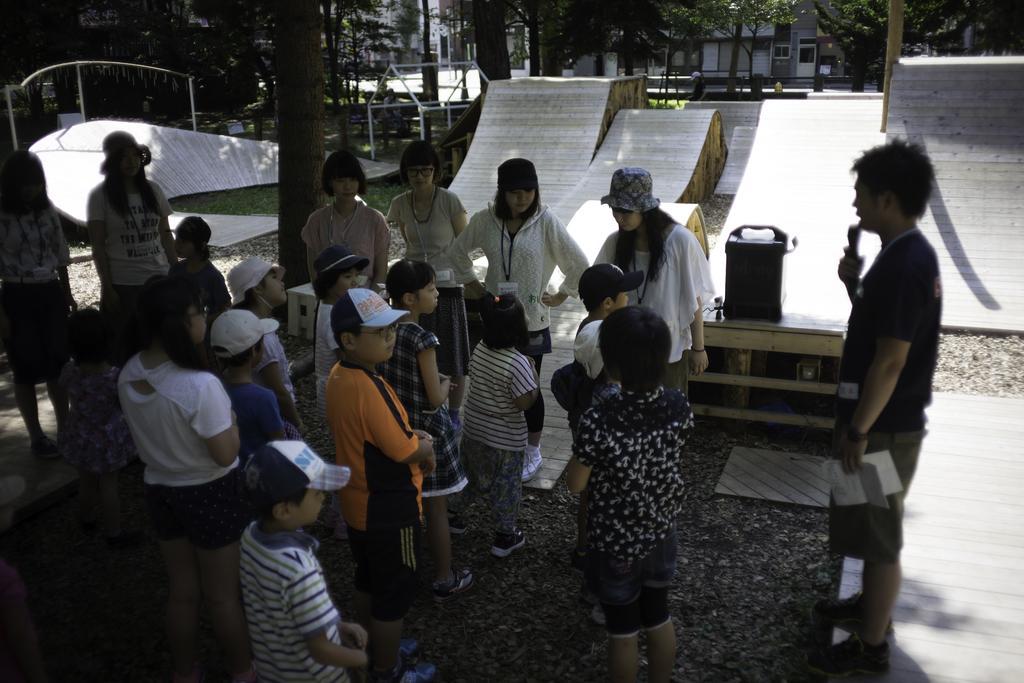How would you summarize this image in a sentence or two? In this picture, we see children are standing. In front of them, we see the girls in white dresses are standing. Behind them, we see a table on which black color object is placed. The man on the right side is holding a paper and a microphone in his hands. He is talking on the microphone. Behind them, we see the ramps. There are trees and buildings in the background. 